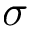<formula> <loc_0><loc_0><loc_500><loc_500>\sigma</formula> 